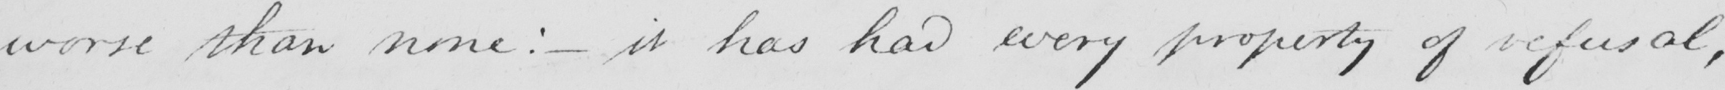What text is written in this handwritten line? worse than none :  _  it has had every property of refusal , 